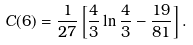Convert formula to latex. <formula><loc_0><loc_0><loc_500><loc_500>C ( 6 ) = \frac { 1 } { 2 7 } \, { \left [ \frac { 4 } { 3 } \ln \frac { 4 } { 3 } - \frac { 1 9 } { 8 1 } \right ] } \, .</formula> 